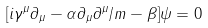<formula> <loc_0><loc_0><loc_500><loc_500>[ i \gamma ^ { \mu } \partial _ { \mu } - \alpha \partial _ { \mu } \partial ^ { \mu } / m - \beta ] \psi = 0 \,</formula> 